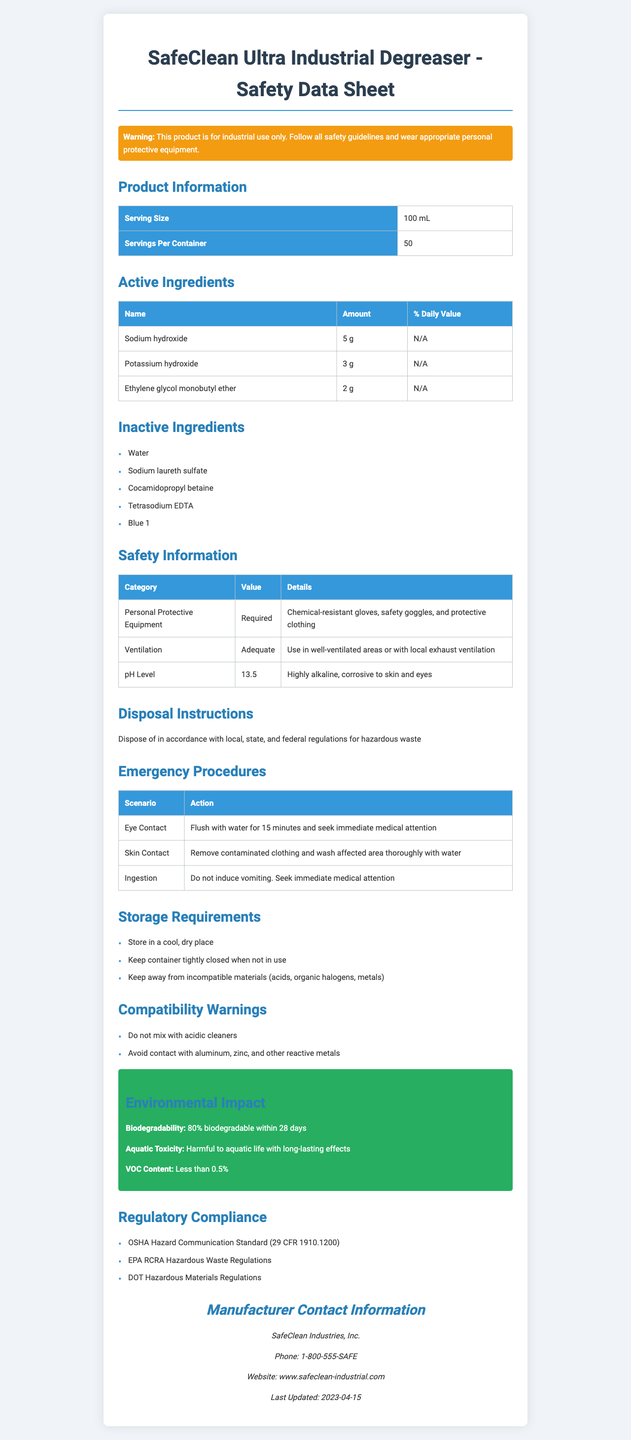what is the serving size of SafeClean Ultra Industrial Degreaser? The serving size of SafeClean Ultra Industrial Degreaser is clearly listed in the 'Product Information' section of the document.
Answer: 100 mL what active ingredient has the highest amount in the product? Sodium hydroxide, listed as 5 g, has the highest amount among the active ingredients listed in the 'Active Ingredients' table.
Answer: Sodium hydroxide how should you respond if the product comes into contact with the eyes? The 'Emergency Procedures' section specifies the action for eye contact scenario.
Answer: Flush with water for 15 minutes and seek immediate medical attention what type of ventilation is recommended when using this product? The 'Ventilation' information under 'Safety Information' mentions using the product in well-ventilated areas or with local exhaust ventilation.
Answer: Use in well-ventilated areas or with local exhaust ventilation what is the aquatics toxicity of SafeClean Ultra Industrial Degreaser? The 'Environmental Impact' section states that the product is harmful to aquatic life with long-lasting effects.
Answer: Harmful to aquatic life with long-lasting effects which of the following is an inactive ingredient in SafeClean Ultra Industrial Degreaser? A. Sodium hydroxide B. Tetrasodium EDTA C. Ethylene glycol monobutyl ether Tetrasodium EDTA is listed under 'Inactive Ingredients,' whereas the other two options are active ingredients.
Answer: B what should you do if the product is ingested? A. Drink milk B. Induce vomiting C. Do not induce vomiting and seek immediate medical attention D. Rest The 'Emergency Procedures' section states that you should not induce vomiting and seek immediate medical attention if the product is ingested.
Answer: C is the product 100% biodegradable within 28 days? The product is 80% biodegradable within 28 days, as mentioned in the 'Environmental Impact' section.
Answer: No summarize the safety and handling guidelines provided in the document. The document outlines detailed information on safe usage, handling, storage, and disposal of the product. It includes mandatory personal protective equipment, ventilation requirements, emergency procedures, storage instructions, compatibility warnings, biodegradability, aquatic toxicity, VOC content, and adherence to specific regulations.
Answer: The document provides comprehensive safety and handling guidelines for SafeClean Ultra Industrial Degreaser, highlighting the need for proper personal protective equipment, adequate ventilation, emergency procedures for various scenarios, safe storage practices, compatibility warnings, and proper disposal. It also outlines the product's environmental impact and regulatory compliance. what is the pH level of SafeClean Ultra Industrial Degreaser? The 'Safety Information' section lists the pH level as 13.5, indicating it is highly alkaline and corrosive to skin and eyes.
Answer: 13.5 how should this product be disposed of? The 'Disposal Instructions' section provides specific guidelines for the disposal of the product.
Answer: Dispose of in accordance with local, state, and federal regulations for hazardous waste who is the manufacturer of SafeClean Ultra Industrial Degreaser? The 'Manufacturer Contact Information' section lists SafeClean Industries, Inc. as the manufacturer.
Answer: SafeClean Industries, Inc. what are the storage requirements for SafeClean Ultra Industrial Degreaser? The 'Storage Requirements' section provides these instructions for storing the product.
Answer: Store in a cool, dry place, keep container tightly closed when not in use, keep away from incompatible materials (acids, organic halogens, metals) what is the percent daily value of sodium hydroxide in the product? The 'Active Ingredients' table lists the percent daily value of sodium hydroxide as N/A.
Answer: N/A what should you do if the product comes into contact with skin? The 'Emergency Procedures' section specifies the action for skin contact scenario.
Answer: Remove contaminated clothing and wash affected area thoroughly with water which section outlines whether this product is harmful to the environment? A. Safety Information B. Disposal Instructions C. Environmental Impact The 'Environmental Impact' section outlines the product's biodegradability, aquatic toxicity, and VOC content, indicating its environmental harm.
Answer: C is the document applicable under OSHA regulations? The 'Regulatory Compliance' section lists the OSHA Hazard Communication Standard (29 CFR 1910.1200) as one of the regulations the product complies with.
Answer: Yes when was the document last updated? The 'Manufacturer Contact Information' section mentions that the document was last updated on 2023-04-15.
Answer: 2023-04-15 how much potassium hydroxide is in the product? The 'Active Ingredients' table lists the amount of potassium hydroxide as 3 g.
Answer: 3 g what specific type of personal protective equipment is required when using this product? The 'Safety Information' section under the 'Personal Protective Equipment' category lists these specific items.
Answer: Chemical-resistant gloves, safety goggles, and protective clothing 